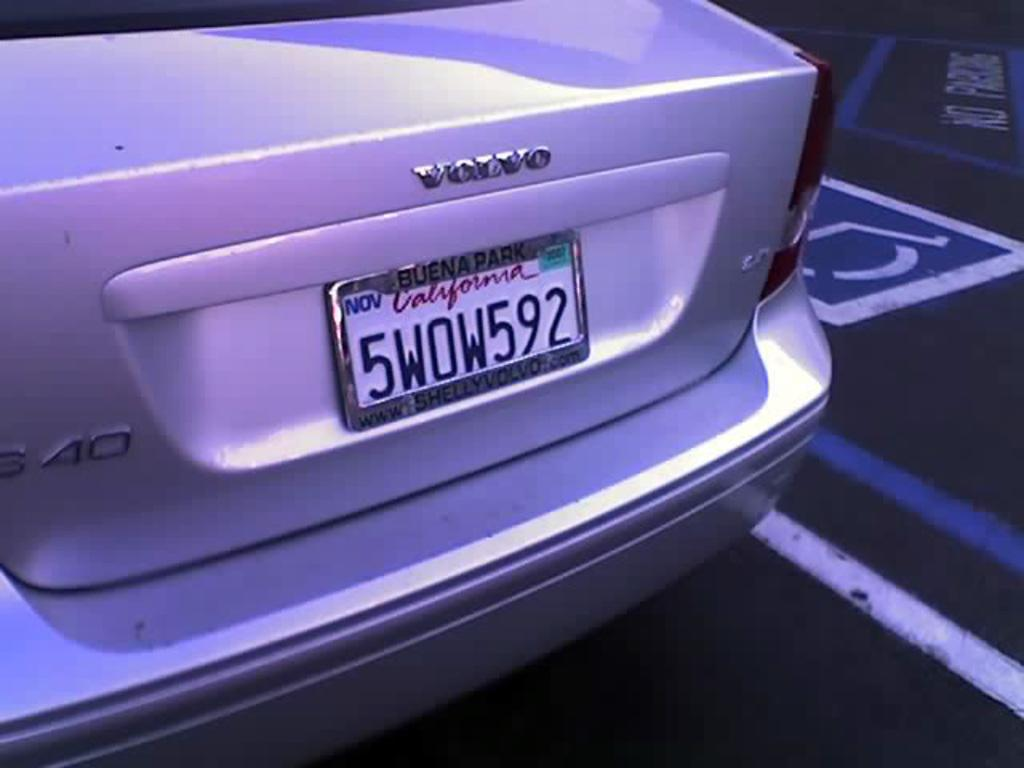<image>
Present a compact description of the photo's key features. The license plate is 5WOW592 and in the California state. 